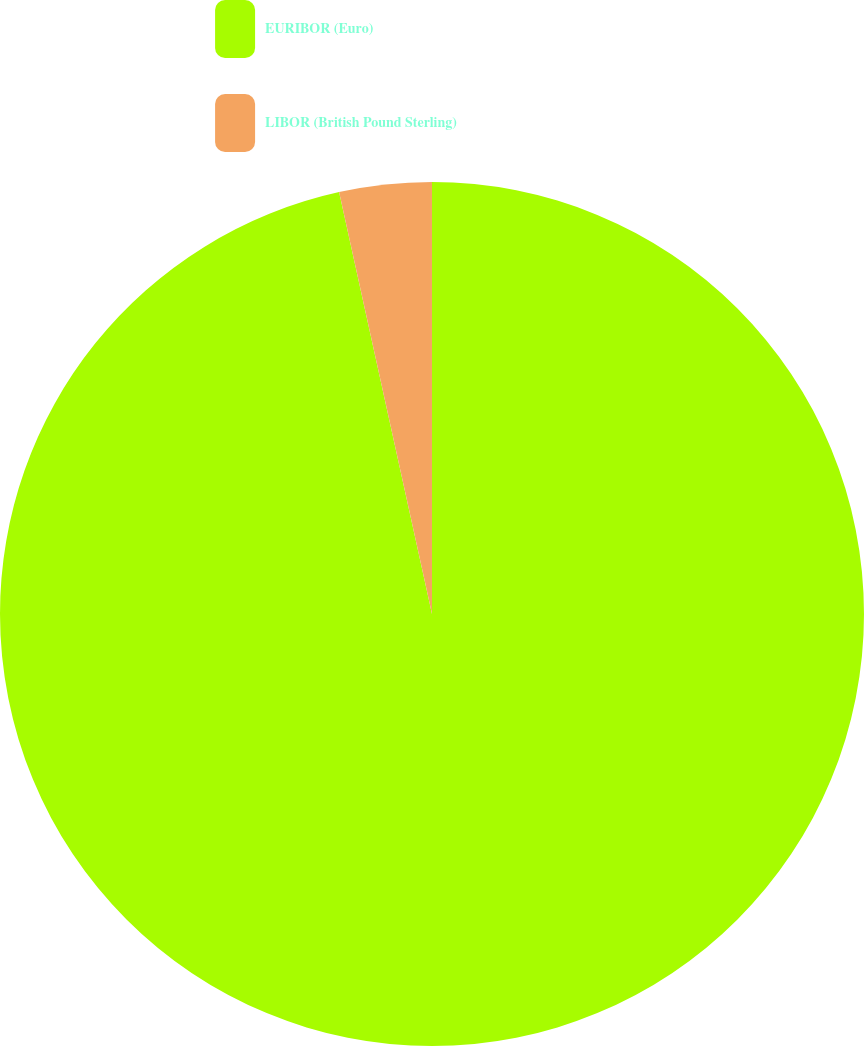<chart> <loc_0><loc_0><loc_500><loc_500><pie_chart><fcel>EURIBOR (Euro)<fcel>LIBOR (British Pound Sterling)<nl><fcel>96.55%<fcel>3.45%<nl></chart> 